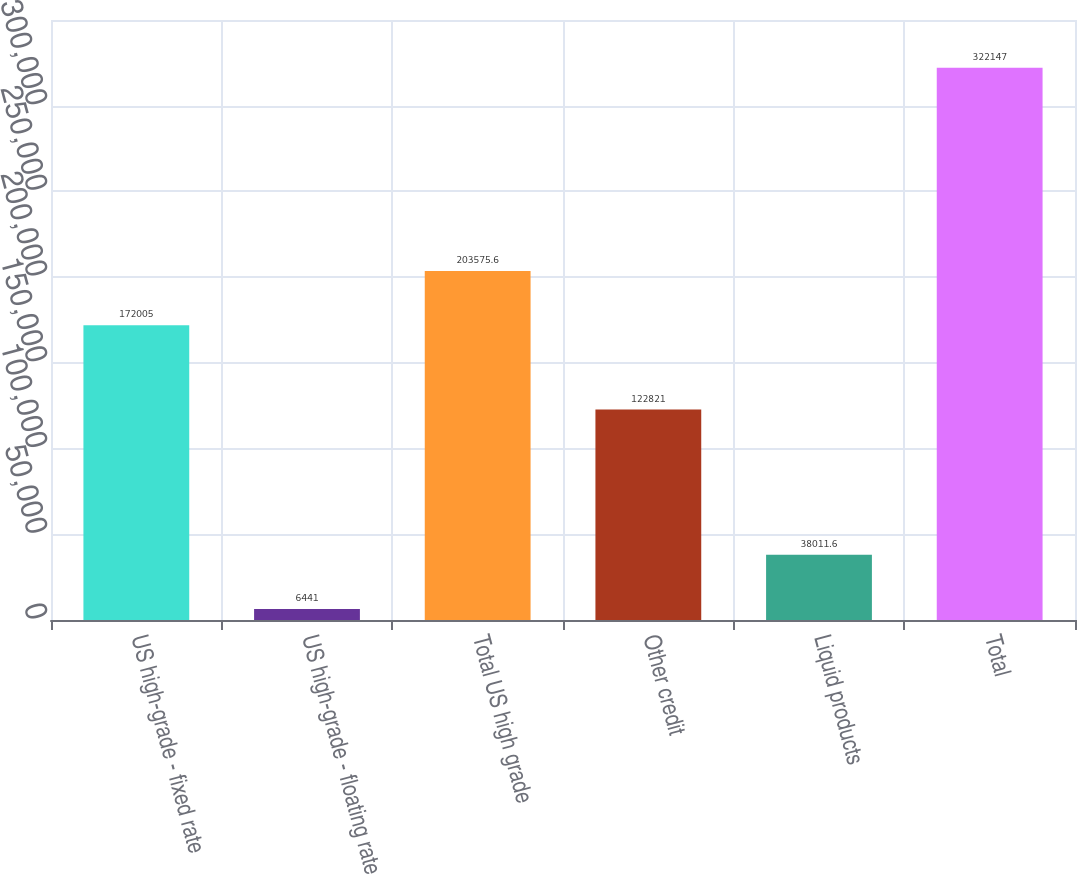Convert chart to OTSL. <chart><loc_0><loc_0><loc_500><loc_500><bar_chart><fcel>US high-grade - fixed rate<fcel>US high-grade - floating rate<fcel>Total US high grade<fcel>Other credit<fcel>Liquid products<fcel>Total<nl><fcel>172005<fcel>6441<fcel>203576<fcel>122821<fcel>38011.6<fcel>322147<nl></chart> 